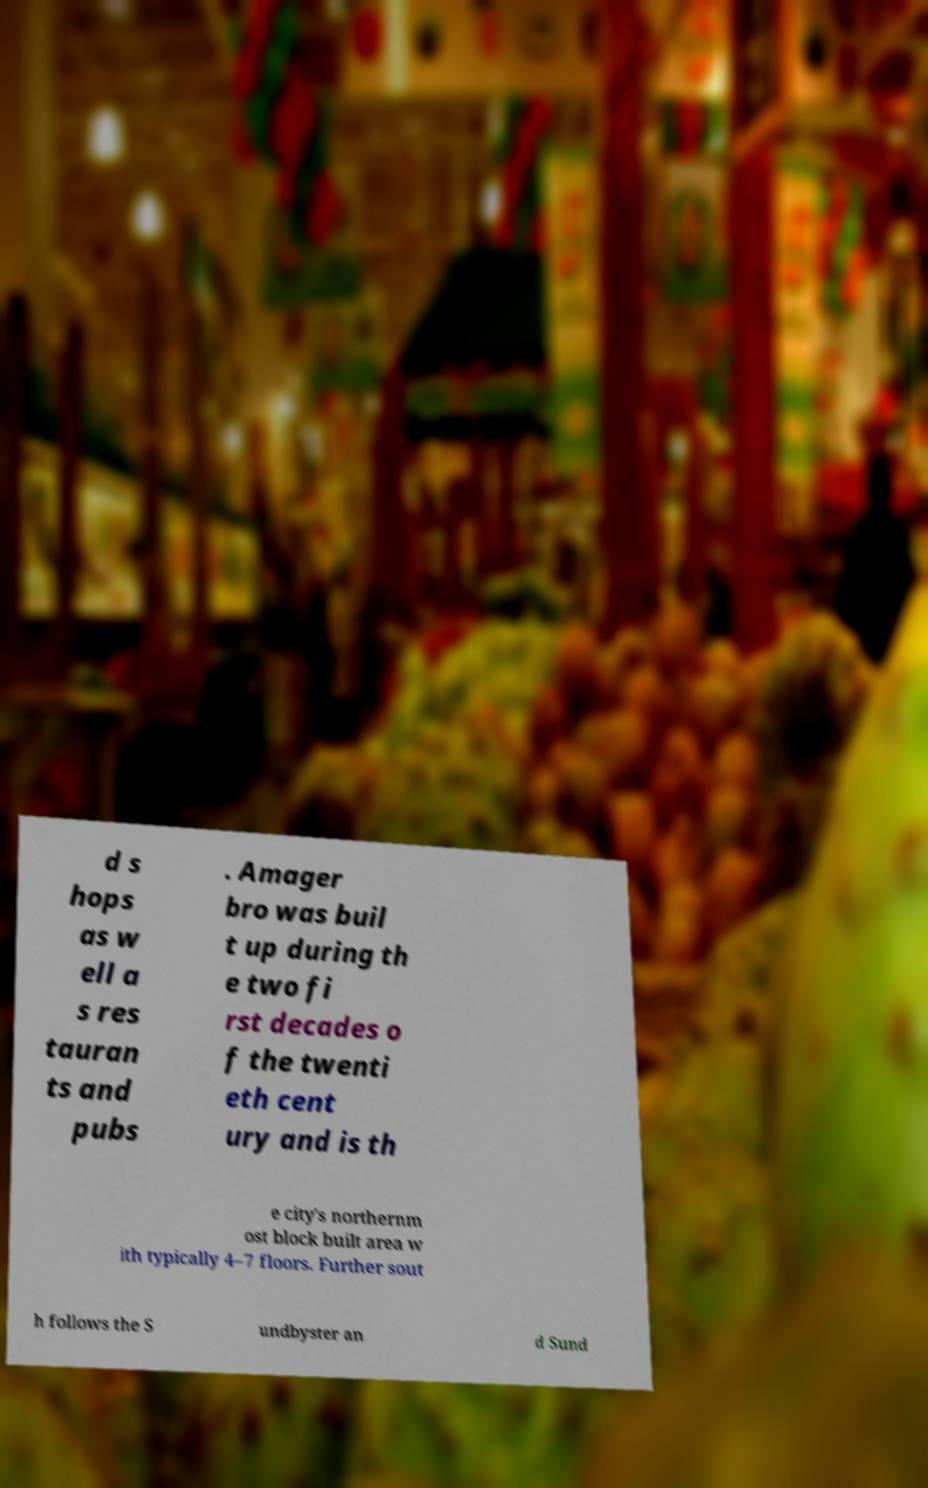Could you extract and type out the text from this image? d s hops as w ell a s res tauran ts and pubs . Amager bro was buil t up during th e two fi rst decades o f the twenti eth cent ury and is th e city's northernm ost block built area w ith typically 4–7 floors. Further sout h follows the S undbyster an d Sund 